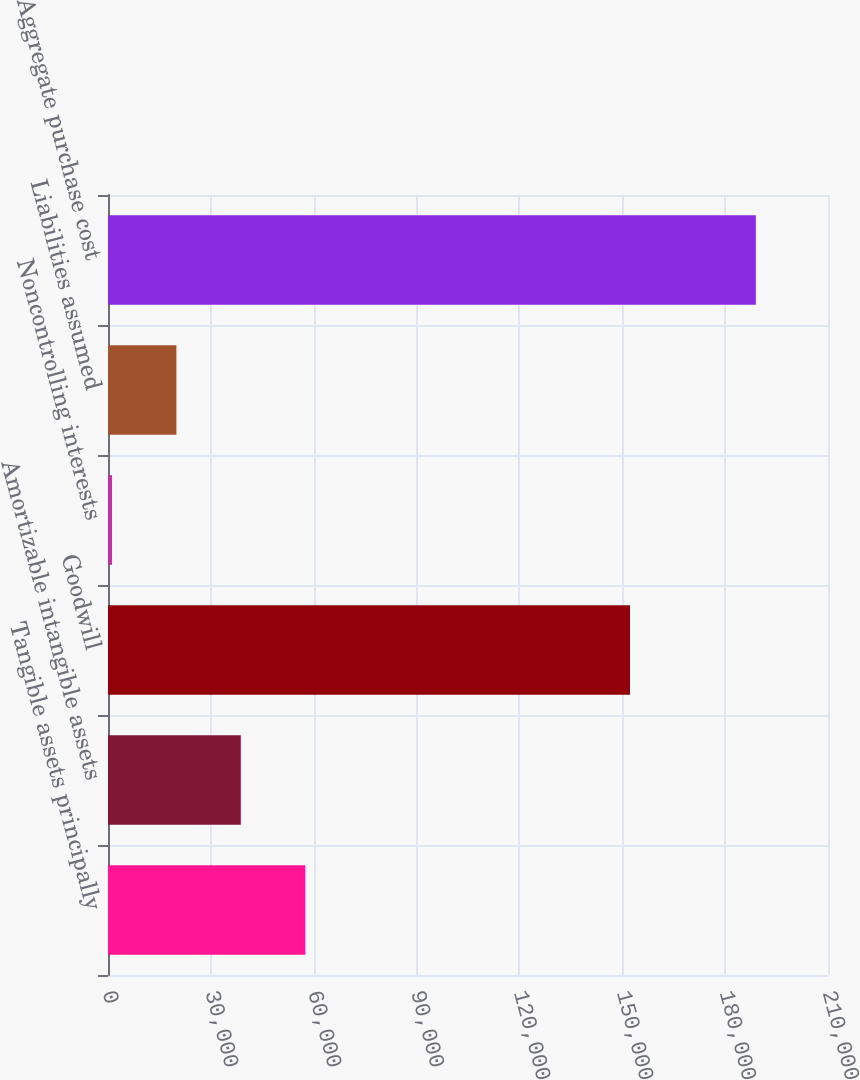Convert chart to OTSL. <chart><loc_0><loc_0><loc_500><loc_500><bar_chart><fcel>Tangible assets principally<fcel>Amortizable intangible assets<fcel>Goodwill<fcel>Noncontrolling interests<fcel>Liabilities assumed<fcel>Aggregate purchase cost<nl><fcel>57505<fcel>38727<fcel>152252<fcel>1171<fcel>19949<fcel>188951<nl></chart> 